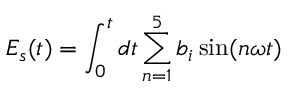<formula> <loc_0><loc_0><loc_500><loc_500>E _ { s } ( t ) = \int _ { 0 } ^ { t } d t \sum _ { n = 1 } ^ { 5 } b _ { i } \sin ( n \omega t )</formula> 